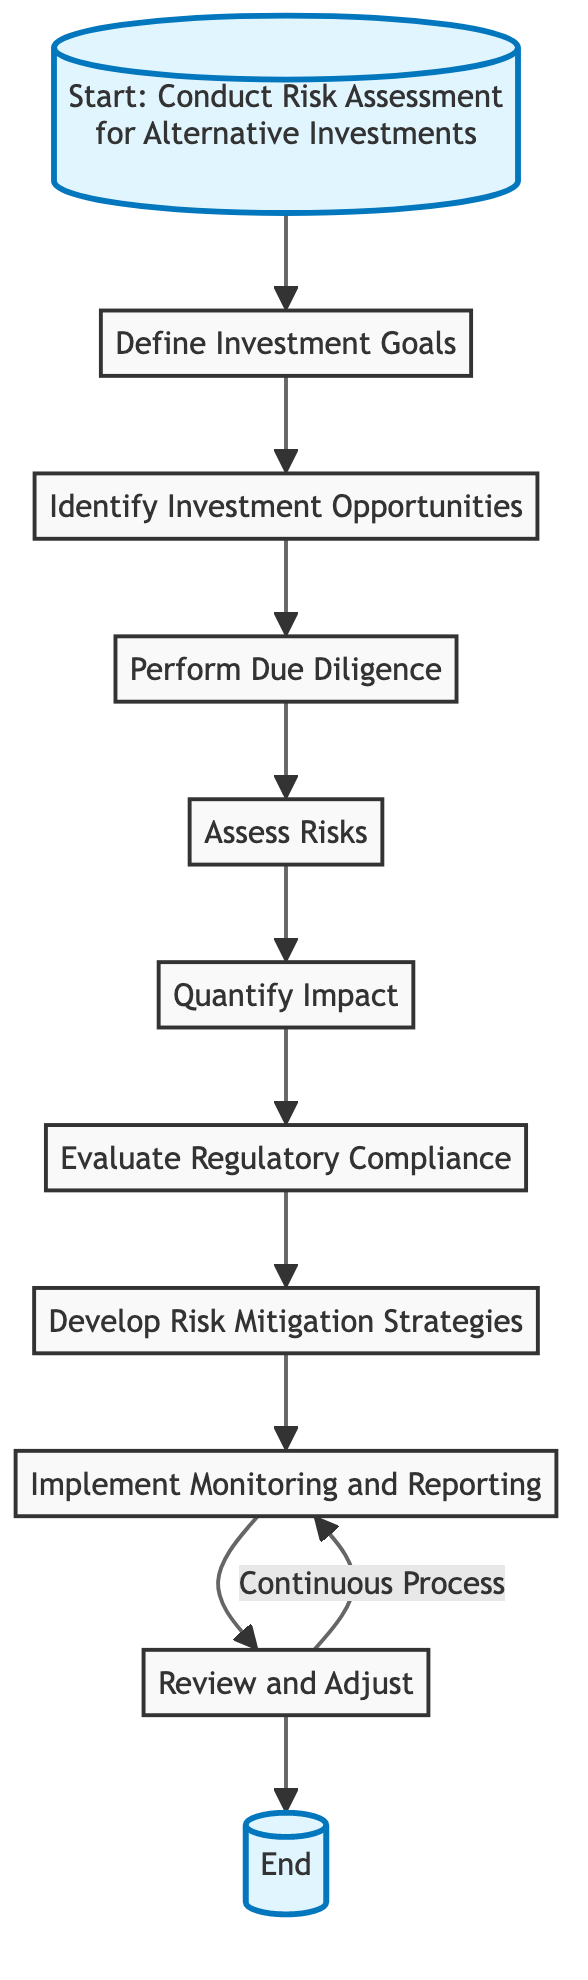What is the first step in the diagram? The first step in the diagram is clearly labeled as "Define Investment Goals," which is the first node connected to the start node.
Answer: Define Investment Goals How many steps are there in the risk assessment process? Counting the listed steps from the diagram, there are a total of nine steps that process through the risk assessment chain starting from defining goals to reviewing and adjusting.
Answer: Nine What is the last step before reaching the end of the process? The last step prior to the end node is "Review and Adjust," which is the final action taken before completing the process.
Answer: Review and Adjust After "Quantify Impact," which step follows? The flow following "Quantify Impact" leads directly to "Evaluate Regulatory Compliance," indicating the next phase in the risk assessment process.
Answer: Evaluate Regulatory Compliance Which steps involve calculations or estimates? The two steps that involve calculations or estimates are "Quantify Impact" and "Assess Risks," as both require numerical analysis related to risk evaluation.
Answer: Quantify Impact, Assess Risks What type of process is indicated by the arrow from "Review and Adjust" back to "Implement Monitoring and Reporting"? The arrow indicates a continuous process, suggesting that reviewing and adjusting is an ongoing loop back into the monitoring and reporting phase for continual improvement.
Answer: Continuous Process What is the function of the "Develop Risk Mitigation Strategies" step? This step focuses on creating strategies specifically intended to minimize the identified risks, providing actionable measures to safeguard investments.
Answer: Minimize identified risks Which step includes ensuring compliance with laws and regulations? The step dedicated to ensuring adherence to laws and regulations is "Evaluate Regulatory Compliance," which focuses on legal obligations related to investments.
Answer: Evaluate Regulatory Compliance How does the diagram depict the relationship between steps? The relationship between steps is shown through directional arrows that illustrate the sequence of actions, guiding from one step to the next, establishing a clear workflow.
Answer: Directional arrows 